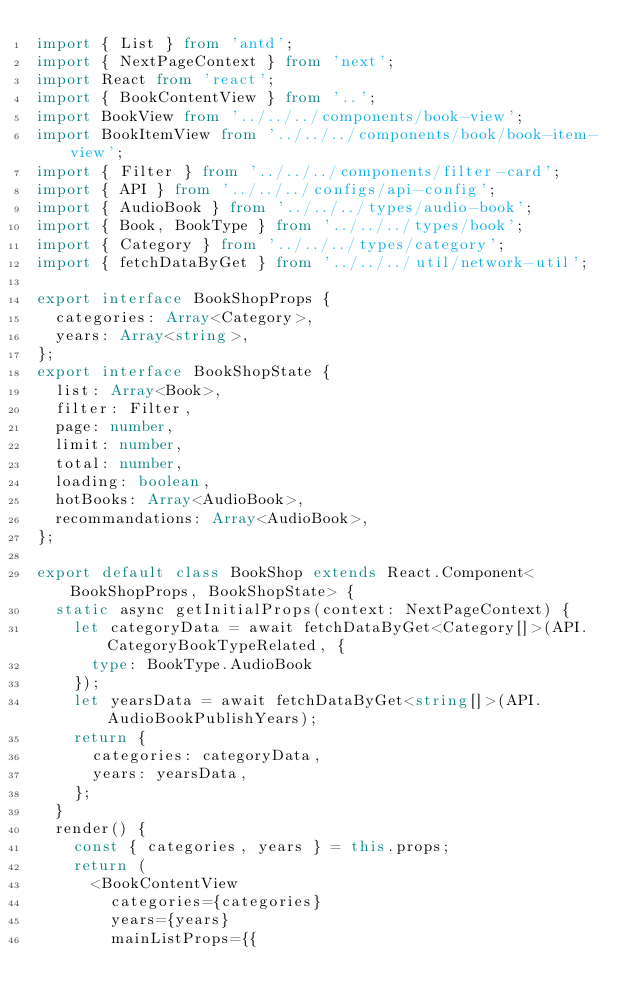<code> <loc_0><loc_0><loc_500><loc_500><_TypeScript_>import { List } from 'antd';
import { NextPageContext } from 'next';
import React from 'react';
import { BookContentView } from '..';
import BookView from '../../../components/book-view';
import BookItemView from '../../../components/book/book-item-view';
import { Filter } from '../../../components/filter-card';
import { API } from '../../../configs/api-config';
import { AudioBook } from '../../../types/audio-book';
import { Book, BookType } from '../../../types/book';
import { Category } from '../../../types/category';
import { fetchDataByGet } from '../../../util/network-util';

export interface BookShopProps {
  categories: Array<Category>,
  years: Array<string>,
};
export interface BookShopState {
  list: Array<Book>,
  filter: Filter,
  page: number,
  limit: number,
  total: number,
  loading: boolean,
  hotBooks: Array<AudioBook>,
  recommandations: Array<AudioBook>,
};

export default class BookShop extends React.Component<BookShopProps, BookShopState> {
  static async getInitialProps(context: NextPageContext) {
    let categoryData = await fetchDataByGet<Category[]>(API.CategoryBookTypeRelated, {
      type: BookType.AudioBook
    });
    let yearsData = await fetchDataByGet<string[]>(API.AudioBookPublishYears);
    return {
      categories: categoryData,
      years: yearsData,
    };
  }
  render() {
    const { categories, years } = this.props;
    return (
      <BookContentView
        categories={categories}
        years={years}
        mainListProps={{</code> 